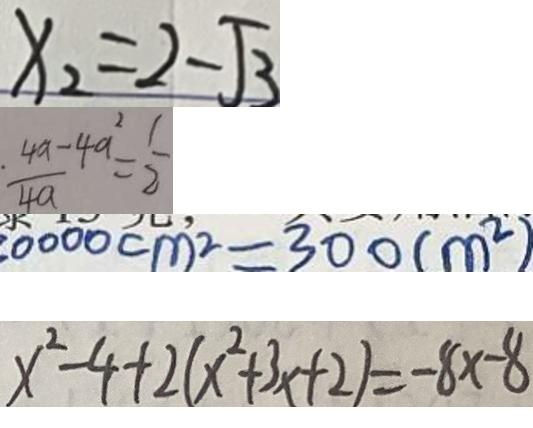<formula> <loc_0><loc_0><loc_500><loc_500>x _ { 2 } = 2 - \sqrt { 3 } 
 \frac { 4 a - 4 a ^ { 2 } } { 4 a } = \frac { 1 } { 2 } 
 3 0 0 0 0 c m ^ { 2 } = 3 0 0 ( m ^ { 2 } ) 
 x ^ { 2 } - 4 + 2 ( x ^ { 2 } + 3 x + 2 ) = - 8 x - 8</formula> 